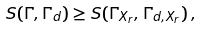<formula> <loc_0><loc_0><loc_500><loc_500>S ( \Gamma , \Gamma _ { d } ) \geq S ( \Gamma _ { X _ { r } } , \Gamma _ { d , X _ { r } } ) \, ,</formula> 